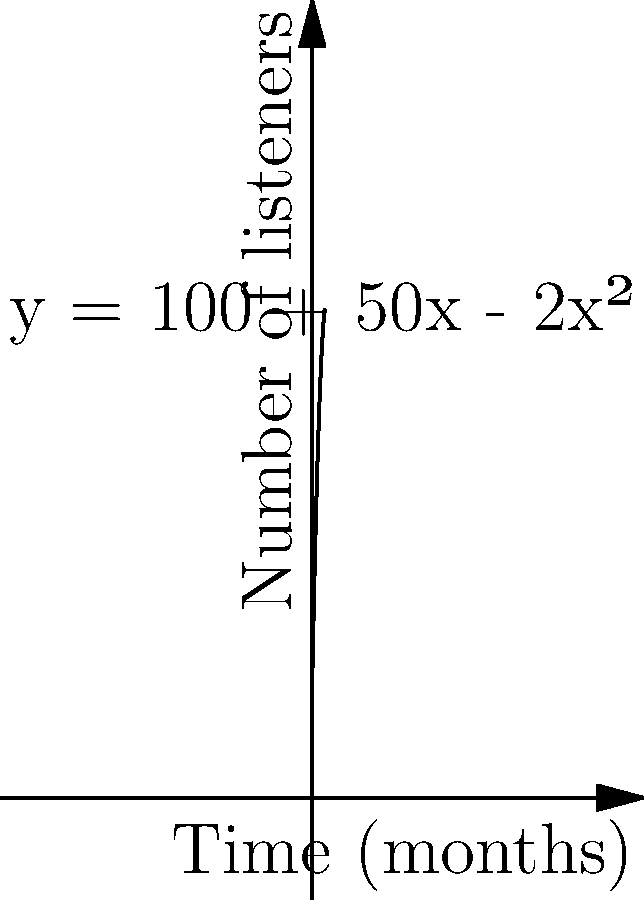As the student leader organizing the podcast host's live talk, you're tracking the growth of listeners over time. The graph shows the number of podcast listeners as a function of time, given by the equation $y = 100 + 50x - 2x^2$, where $y$ is the number of listeners and $x$ is the time in months. At what point in time is the rate of change of listeners equal to zero? To find when the rate of change of listeners is zero, we need to follow these steps:

1) The rate of change is represented by the derivative of the function. Let's call the original function $f(x)$.

   $f(x) = 100 + 50x - 2x^2$

2) Take the derivative of $f(x)$ to get $f'(x)$:

   $f'(x) = 50 - 4x$

3) The rate of change is zero when $f'(x) = 0$. So, let's solve the equation:

   $50 - 4x = 0$
   $-4x = -50$
   $x = \frac{50}{4} = 12.5$

4) Therefore, the rate of change is zero when $x = 12.5$ months.

This point represents the maximum number of listeners before the podcast starts losing audience, which is crucial information for planning the live talk event.
Answer: 12.5 months 